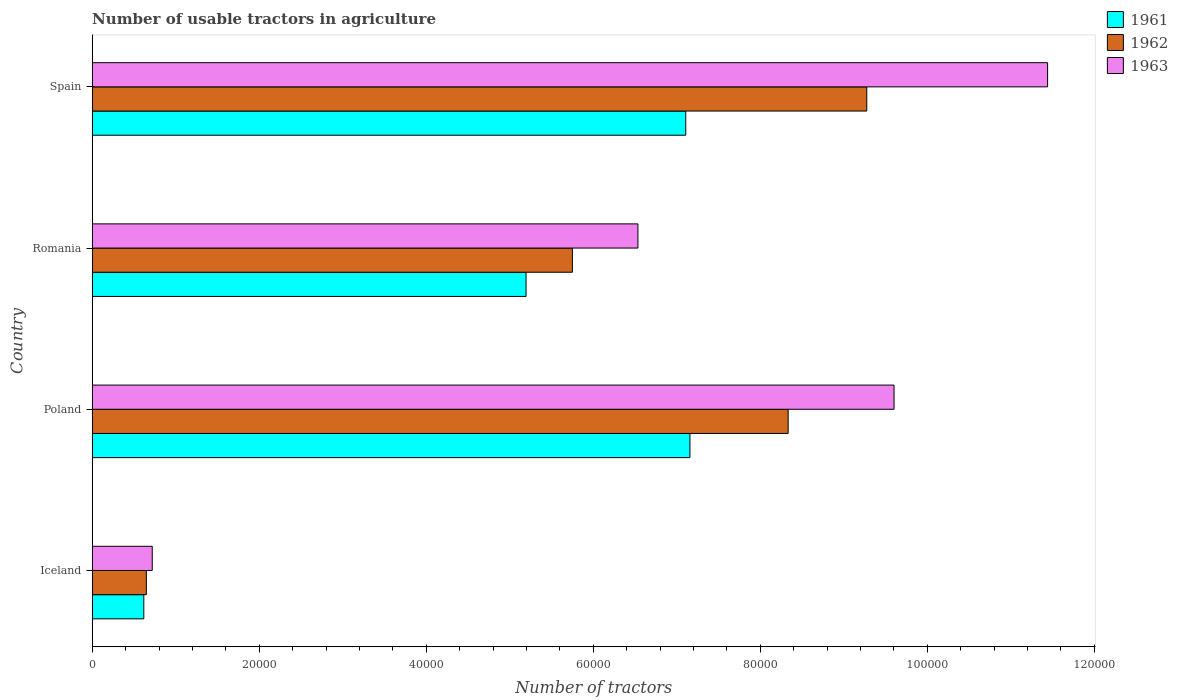How many groups of bars are there?
Provide a succinct answer. 4. Are the number of bars per tick equal to the number of legend labels?
Ensure brevity in your answer.  Yes. Are the number of bars on each tick of the Y-axis equal?
Ensure brevity in your answer.  Yes. How many bars are there on the 4th tick from the bottom?
Keep it short and to the point. 3. What is the label of the 3rd group of bars from the top?
Your response must be concise. Poland. What is the number of usable tractors in agriculture in 1961 in Poland?
Make the answer very short. 7.16e+04. Across all countries, what is the maximum number of usable tractors in agriculture in 1962?
Make the answer very short. 9.28e+04. Across all countries, what is the minimum number of usable tractors in agriculture in 1963?
Provide a succinct answer. 7187. What is the total number of usable tractors in agriculture in 1963 in the graph?
Ensure brevity in your answer.  2.83e+05. What is the difference between the number of usable tractors in agriculture in 1962 in Poland and that in Spain?
Ensure brevity in your answer.  -9414. What is the difference between the number of usable tractors in agriculture in 1962 in Romania and the number of usable tractors in agriculture in 1961 in Spain?
Offer a terse response. -1.36e+04. What is the average number of usable tractors in agriculture in 1962 per country?
Ensure brevity in your answer.  6.00e+04. What is the difference between the number of usable tractors in agriculture in 1962 and number of usable tractors in agriculture in 1961 in Iceland?
Your answer should be very brief. 302. What is the ratio of the number of usable tractors in agriculture in 1963 in Iceland to that in Romania?
Make the answer very short. 0.11. Is the difference between the number of usable tractors in agriculture in 1962 in Poland and Romania greater than the difference between the number of usable tractors in agriculture in 1961 in Poland and Romania?
Offer a very short reply. Yes. What is the difference between the highest and the second highest number of usable tractors in agriculture in 1962?
Make the answer very short. 9414. What is the difference between the highest and the lowest number of usable tractors in agriculture in 1963?
Provide a succinct answer. 1.07e+05. In how many countries, is the number of usable tractors in agriculture in 1962 greater than the average number of usable tractors in agriculture in 1962 taken over all countries?
Provide a succinct answer. 2. Is the sum of the number of usable tractors in agriculture in 1962 in Poland and Spain greater than the maximum number of usable tractors in agriculture in 1963 across all countries?
Make the answer very short. Yes. What does the 3rd bar from the top in Spain represents?
Your answer should be very brief. 1961. Is it the case that in every country, the sum of the number of usable tractors in agriculture in 1962 and number of usable tractors in agriculture in 1961 is greater than the number of usable tractors in agriculture in 1963?
Your answer should be very brief. Yes. How many bars are there?
Your answer should be compact. 12. How many countries are there in the graph?
Keep it short and to the point. 4. Where does the legend appear in the graph?
Your response must be concise. Top right. How are the legend labels stacked?
Your answer should be very brief. Vertical. What is the title of the graph?
Ensure brevity in your answer.  Number of usable tractors in agriculture. What is the label or title of the X-axis?
Your response must be concise. Number of tractors. What is the label or title of the Y-axis?
Provide a short and direct response. Country. What is the Number of tractors of 1961 in Iceland?
Your answer should be very brief. 6177. What is the Number of tractors in 1962 in Iceland?
Keep it short and to the point. 6479. What is the Number of tractors of 1963 in Iceland?
Offer a very short reply. 7187. What is the Number of tractors in 1961 in Poland?
Your answer should be compact. 7.16e+04. What is the Number of tractors in 1962 in Poland?
Provide a succinct answer. 8.33e+04. What is the Number of tractors in 1963 in Poland?
Make the answer very short. 9.60e+04. What is the Number of tractors of 1961 in Romania?
Your answer should be very brief. 5.20e+04. What is the Number of tractors of 1962 in Romania?
Make the answer very short. 5.75e+04. What is the Number of tractors in 1963 in Romania?
Your response must be concise. 6.54e+04. What is the Number of tractors in 1961 in Spain?
Provide a succinct answer. 7.11e+04. What is the Number of tractors in 1962 in Spain?
Keep it short and to the point. 9.28e+04. What is the Number of tractors of 1963 in Spain?
Your response must be concise. 1.14e+05. Across all countries, what is the maximum Number of tractors of 1961?
Your answer should be very brief. 7.16e+04. Across all countries, what is the maximum Number of tractors in 1962?
Make the answer very short. 9.28e+04. Across all countries, what is the maximum Number of tractors in 1963?
Provide a short and direct response. 1.14e+05. Across all countries, what is the minimum Number of tractors of 1961?
Your answer should be very brief. 6177. Across all countries, what is the minimum Number of tractors of 1962?
Keep it short and to the point. 6479. Across all countries, what is the minimum Number of tractors in 1963?
Provide a short and direct response. 7187. What is the total Number of tractors in 1961 in the graph?
Ensure brevity in your answer.  2.01e+05. What is the total Number of tractors of 1962 in the graph?
Your answer should be compact. 2.40e+05. What is the total Number of tractors of 1963 in the graph?
Give a very brief answer. 2.83e+05. What is the difference between the Number of tractors of 1961 in Iceland and that in Poland?
Make the answer very short. -6.54e+04. What is the difference between the Number of tractors in 1962 in Iceland and that in Poland?
Provide a succinct answer. -7.69e+04. What is the difference between the Number of tractors in 1963 in Iceland and that in Poland?
Provide a succinct answer. -8.88e+04. What is the difference between the Number of tractors of 1961 in Iceland and that in Romania?
Your response must be concise. -4.58e+04. What is the difference between the Number of tractors of 1962 in Iceland and that in Romania?
Keep it short and to the point. -5.10e+04. What is the difference between the Number of tractors of 1963 in Iceland and that in Romania?
Give a very brief answer. -5.82e+04. What is the difference between the Number of tractors in 1961 in Iceland and that in Spain?
Your answer should be compact. -6.49e+04. What is the difference between the Number of tractors of 1962 in Iceland and that in Spain?
Your answer should be very brief. -8.63e+04. What is the difference between the Number of tractors in 1963 in Iceland and that in Spain?
Your response must be concise. -1.07e+05. What is the difference between the Number of tractors in 1961 in Poland and that in Romania?
Give a very brief answer. 1.96e+04. What is the difference between the Number of tractors in 1962 in Poland and that in Romania?
Ensure brevity in your answer.  2.58e+04. What is the difference between the Number of tractors of 1963 in Poland and that in Romania?
Offer a terse response. 3.07e+04. What is the difference between the Number of tractors in 1962 in Poland and that in Spain?
Keep it short and to the point. -9414. What is the difference between the Number of tractors of 1963 in Poland and that in Spain?
Ensure brevity in your answer.  -1.84e+04. What is the difference between the Number of tractors in 1961 in Romania and that in Spain?
Offer a very short reply. -1.91e+04. What is the difference between the Number of tractors of 1962 in Romania and that in Spain?
Your answer should be very brief. -3.53e+04. What is the difference between the Number of tractors in 1963 in Romania and that in Spain?
Provide a succinct answer. -4.91e+04. What is the difference between the Number of tractors of 1961 in Iceland and the Number of tractors of 1962 in Poland?
Offer a terse response. -7.72e+04. What is the difference between the Number of tractors of 1961 in Iceland and the Number of tractors of 1963 in Poland?
Provide a short and direct response. -8.98e+04. What is the difference between the Number of tractors in 1962 in Iceland and the Number of tractors in 1963 in Poland?
Keep it short and to the point. -8.95e+04. What is the difference between the Number of tractors in 1961 in Iceland and the Number of tractors in 1962 in Romania?
Provide a succinct answer. -5.13e+04. What is the difference between the Number of tractors in 1961 in Iceland and the Number of tractors in 1963 in Romania?
Give a very brief answer. -5.92e+04. What is the difference between the Number of tractors in 1962 in Iceland and the Number of tractors in 1963 in Romania?
Provide a succinct answer. -5.89e+04. What is the difference between the Number of tractors in 1961 in Iceland and the Number of tractors in 1962 in Spain?
Your response must be concise. -8.66e+04. What is the difference between the Number of tractors of 1961 in Iceland and the Number of tractors of 1963 in Spain?
Offer a terse response. -1.08e+05. What is the difference between the Number of tractors of 1962 in Iceland and the Number of tractors of 1963 in Spain?
Ensure brevity in your answer.  -1.08e+05. What is the difference between the Number of tractors in 1961 in Poland and the Number of tractors in 1962 in Romania?
Give a very brief answer. 1.41e+04. What is the difference between the Number of tractors in 1961 in Poland and the Number of tractors in 1963 in Romania?
Your answer should be very brief. 6226. What is the difference between the Number of tractors in 1962 in Poland and the Number of tractors in 1963 in Romania?
Give a very brief answer. 1.80e+04. What is the difference between the Number of tractors in 1961 in Poland and the Number of tractors in 1962 in Spain?
Make the answer very short. -2.12e+04. What is the difference between the Number of tractors of 1961 in Poland and the Number of tractors of 1963 in Spain?
Your answer should be compact. -4.28e+04. What is the difference between the Number of tractors of 1962 in Poland and the Number of tractors of 1963 in Spain?
Offer a terse response. -3.11e+04. What is the difference between the Number of tractors of 1961 in Romania and the Number of tractors of 1962 in Spain?
Make the answer very short. -4.08e+04. What is the difference between the Number of tractors in 1961 in Romania and the Number of tractors in 1963 in Spain?
Make the answer very short. -6.25e+04. What is the difference between the Number of tractors of 1962 in Romania and the Number of tractors of 1963 in Spain?
Your answer should be very brief. -5.69e+04. What is the average Number of tractors in 1961 per country?
Keep it short and to the point. 5.02e+04. What is the average Number of tractors in 1962 per country?
Provide a short and direct response. 6.00e+04. What is the average Number of tractors in 1963 per country?
Your answer should be very brief. 7.07e+04. What is the difference between the Number of tractors in 1961 and Number of tractors in 1962 in Iceland?
Provide a succinct answer. -302. What is the difference between the Number of tractors in 1961 and Number of tractors in 1963 in Iceland?
Provide a short and direct response. -1010. What is the difference between the Number of tractors of 1962 and Number of tractors of 1963 in Iceland?
Offer a very short reply. -708. What is the difference between the Number of tractors of 1961 and Number of tractors of 1962 in Poland?
Offer a terse response. -1.18e+04. What is the difference between the Number of tractors of 1961 and Number of tractors of 1963 in Poland?
Offer a terse response. -2.44e+04. What is the difference between the Number of tractors of 1962 and Number of tractors of 1963 in Poland?
Provide a short and direct response. -1.27e+04. What is the difference between the Number of tractors of 1961 and Number of tractors of 1962 in Romania?
Provide a succinct answer. -5548. What is the difference between the Number of tractors of 1961 and Number of tractors of 1963 in Romania?
Offer a very short reply. -1.34e+04. What is the difference between the Number of tractors of 1962 and Number of tractors of 1963 in Romania?
Offer a terse response. -7851. What is the difference between the Number of tractors of 1961 and Number of tractors of 1962 in Spain?
Your response must be concise. -2.17e+04. What is the difference between the Number of tractors in 1961 and Number of tractors in 1963 in Spain?
Keep it short and to the point. -4.33e+04. What is the difference between the Number of tractors of 1962 and Number of tractors of 1963 in Spain?
Provide a short and direct response. -2.17e+04. What is the ratio of the Number of tractors in 1961 in Iceland to that in Poland?
Your answer should be very brief. 0.09. What is the ratio of the Number of tractors of 1962 in Iceland to that in Poland?
Provide a short and direct response. 0.08. What is the ratio of the Number of tractors in 1963 in Iceland to that in Poland?
Your response must be concise. 0.07. What is the ratio of the Number of tractors in 1961 in Iceland to that in Romania?
Your answer should be very brief. 0.12. What is the ratio of the Number of tractors of 1962 in Iceland to that in Romania?
Keep it short and to the point. 0.11. What is the ratio of the Number of tractors of 1963 in Iceland to that in Romania?
Provide a succinct answer. 0.11. What is the ratio of the Number of tractors of 1961 in Iceland to that in Spain?
Offer a terse response. 0.09. What is the ratio of the Number of tractors in 1962 in Iceland to that in Spain?
Your response must be concise. 0.07. What is the ratio of the Number of tractors of 1963 in Iceland to that in Spain?
Ensure brevity in your answer.  0.06. What is the ratio of the Number of tractors of 1961 in Poland to that in Romania?
Offer a very short reply. 1.38. What is the ratio of the Number of tractors of 1962 in Poland to that in Romania?
Offer a terse response. 1.45. What is the ratio of the Number of tractors in 1963 in Poland to that in Romania?
Offer a terse response. 1.47. What is the ratio of the Number of tractors of 1961 in Poland to that in Spain?
Offer a very short reply. 1.01. What is the ratio of the Number of tractors of 1962 in Poland to that in Spain?
Give a very brief answer. 0.9. What is the ratio of the Number of tractors of 1963 in Poland to that in Spain?
Offer a very short reply. 0.84. What is the ratio of the Number of tractors of 1961 in Romania to that in Spain?
Offer a very short reply. 0.73. What is the ratio of the Number of tractors of 1962 in Romania to that in Spain?
Provide a succinct answer. 0.62. What is the ratio of the Number of tractors in 1963 in Romania to that in Spain?
Provide a succinct answer. 0.57. What is the difference between the highest and the second highest Number of tractors in 1962?
Give a very brief answer. 9414. What is the difference between the highest and the second highest Number of tractors in 1963?
Keep it short and to the point. 1.84e+04. What is the difference between the highest and the lowest Number of tractors of 1961?
Your response must be concise. 6.54e+04. What is the difference between the highest and the lowest Number of tractors of 1962?
Make the answer very short. 8.63e+04. What is the difference between the highest and the lowest Number of tractors of 1963?
Provide a succinct answer. 1.07e+05. 